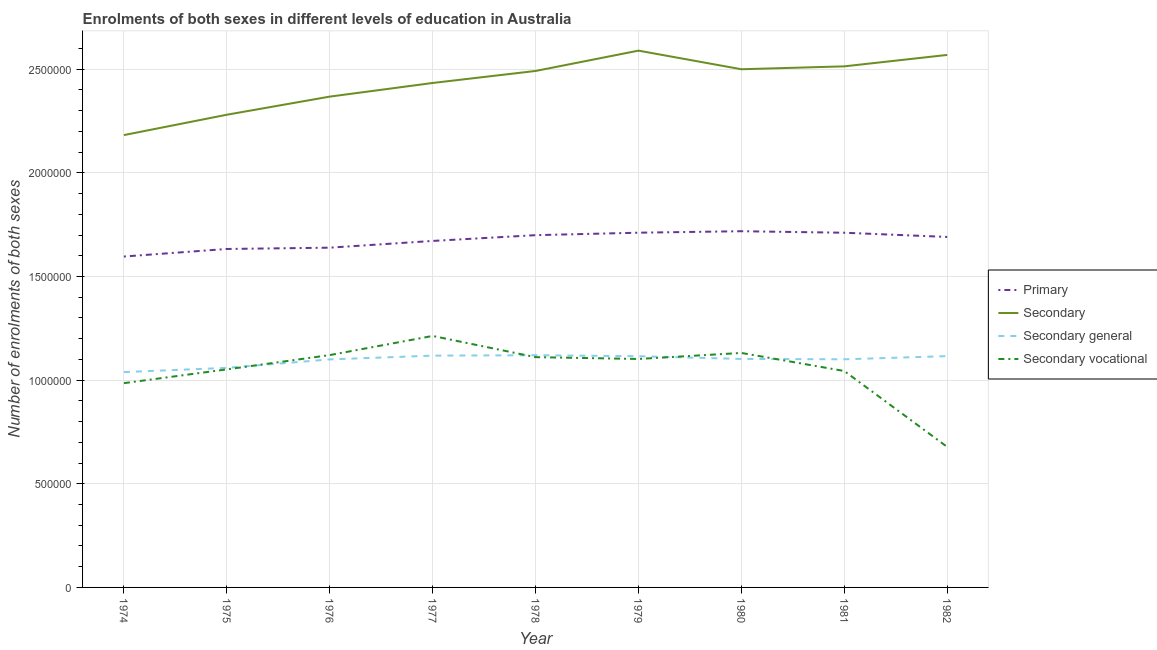Is the number of lines equal to the number of legend labels?
Keep it short and to the point. Yes. What is the number of enrolments in primary education in 1981?
Make the answer very short. 1.71e+06. Across all years, what is the maximum number of enrolments in secondary general education?
Your answer should be compact. 1.12e+06. Across all years, what is the minimum number of enrolments in secondary education?
Keep it short and to the point. 2.18e+06. In which year was the number of enrolments in secondary general education maximum?
Make the answer very short. 1978. In which year was the number of enrolments in secondary education minimum?
Your answer should be compact. 1974. What is the total number of enrolments in secondary general education in the graph?
Provide a succinct answer. 9.87e+06. What is the difference between the number of enrolments in secondary general education in 1978 and that in 1979?
Give a very brief answer. 4783. What is the difference between the number of enrolments in secondary education in 1982 and the number of enrolments in secondary vocational education in 1975?
Your answer should be compact. 1.52e+06. What is the average number of enrolments in secondary vocational education per year?
Your response must be concise. 1.05e+06. In the year 1976, what is the difference between the number of enrolments in secondary vocational education and number of enrolments in primary education?
Keep it short and to the point. -5.18e+05. In how many years, is the number of enrolments in secondary education greater than 400000?
Offer a terse response. 9. What is the ratio of the number of enrolments in secondary education in 1976 to that in 1979?
Your response must be concise. 0.91. What is the difference between the highest and the second highest number of enrolments in secondary general education?
Offer a terse response. 2012. What is the difference between the highest and the lowest number of enrolments in secondary education?
Give a very brief answer. 4.07e+05. In how many years, is the number of enrolments in secondary vocational education greater than the average number of enrolments in secondary vocational education taken over all years?
Offer a terse response. 6. Is the sum of the number of enrolments in primary education in 1976 and 1982 greater than the maximum number of enrolments in secondary education across all years?
Offer a very short reply. Yes. Is it the case that in every year, the sum of the number of enrolments in secondary education and number of enrolments in secondary general education is greater than the sum of number of enrolments in primary education and number of enrolments in secondary vocational education?
Your answer should be compact. No. Is the number of enrolments in secondary general education strictly greater than the number of enrolments in secondary vocational education over the years?
Make the answer very short. No. Is the number of enrolments in secondary vocational education strictly less than the number of enrolments in secondary education over the years?
Provide a succinct answer. Yes. How many years are there in the graph?
Offer a very short reply. 9. What is the difference between two consecutive major ticks on the Y-axis?
Ensure brevity in your answer.  5.00e+05. Are the values on the major ticks of Y-axis written in scientific E-notation?
Keep it short and to the point. No. How are the legend labels stacked?
Offer a terse response. Vertical. What is the title of the graph?
Your answer should be compact. Enrolments of both sexes in different levels of education in Australia. What is the label or title of the Y-axis?
Keep it short and to the point. Number of enrolments of both sexes. What is the Number of enrolments of both sexes in Primary in 1974?
Offer a terse response. 1.60e+06. What is the Number of enrolments of both sexes in Secondary in 1974?
Offer a terse response. 2.18e+06. What is the Number of enrolments of both sexes in Secondary general in 1974?
Offer a terse response. 1.04e+06. What is the Number of enrolments of both sexes in Secondary vocational in 1974?
Your response must be concise. 9.85e+05. What is the Number of enrolments of both sexes in Primary in 1975?
Make the answer very short. 1.63e+06. What is the Number of enrolments of both sexes in Secondary in 1975?
Offer a very short reply. 2.28e+06. What is the Number of enrolments of both sexes in Secondary general in 1975?
Offer a very short reply. 1.06e+06. What is the Number of enrolments of both sexes of Secondary vocational in 1975?
Your answer should be compact. 1.05e+06. What is the Number of enrolments of both sexes of Primary in 1976?
Offer a very short reply. 1.64e+06. What is the Number of enrolments of both sexes in Secondary in 1976?
Offer a terse response. 2.37e+06. What is the Number of enrolments of both sexes of Secondary general in 1976?
Provide a succinct answer. 1.10e+06. What is the Number of enrolments of both sexes of Secondary vocational in 1976?
Give a very brief answer. 1.12e+06. What is the Number of enrolments of both sexes in Primary in 1977?
Give a very brief answer. 1.67e+06. What is the Number of enrolments of both sexes of Secondary in 1977?
Give a very brief answer. 2.43e+06. What is the Number of enrolments of both sexes of Secondary general in 1977?
Your answer should be very brief. 1.12e+06. What is the Number of enrolments of both sexes in Secondary vocational in 1977?
Offer a terse response. 1.21e+06. What is the Number of enrolments of both sexes of Primary in 1978?
Keep it short and to the point. 1.70e+06. What is the Number of enrolments of both sexes of Secondary in 1978?
Make the answer very short. 2.49e+06. What is the Number of enrolments of both sexes of Secondary general in 1978?
Provide a succinct answer. 1.12e+06. What is the Number of enrolments of both sexes of Secondary vocational in 1978?
Your answer should be compact. 1.11e+06. What is the Number of enrolments of both sexes in Primary in 1979?
Your response must be concise. 1.71e+06. What is the Number of enrolments of both sexes of Secondary in 1979?
Your answer should be very brief. 2.59e+06. What is the Number of enrolments of both sexes in Secondary general in 1979?
Provide a succinct answer. 1.12e+06. What is the Number of enrolments of both sexes of Secondary vocational in 1979?
Ensure brevity in your answer.  1.10e+06. What is the Number of enrolments of both sexes of Primary in 1980?
Provide a short and direct response. 1.72e+06. What is the Number of enrolments of both sexes in Secondary in 1980?
Keep it short and to the point. 2.50e+06. What is the Number of enrolments of both sexes in Secondary general in 1980?
Ensure brevity in your answer.  1.10e+06. What is the Number of enrolments of both sexes in Secondary vocational in 1980?
Your response must be concise. 1.13e+06. What is the Number of enrolments of both sexes of Primary in 1981?
Your answer should be compact. 1.71e+06. What is the Number of enrolments of both sexes of Secondary in 1981?
Give a very brief answer. 2.51e+06. What is the Number of enrolments of both sexes of Secondary general in 1981?
Your answer should be compact. 1.10e+06. What is the Number of enrolments of both sexes of Secondary vocational in 1981?
Keep it short and to the point. 1.04e+06. What is the Number of enrolments of both sexes of Primary in 1982?
Your answer should be compact. 1.69e+06. What is the Number of enrolments of both sexes in Secondary in 1982?
Provide a short and direct response. 2.57e+06. What is the Number of enrolments of both sexes of Secondary general in 1982?
Offer a very short reply. 1.12e+06. What is the Number of enrolments of both sexes of Secondary vocational in 1982?
Keep it short and to the point. 6.78e+05. Across all years, what is the maximum Number of enrolments of both sexes of Primary?
Your response must be concise. 1.72e+06. Across all years, what is the maximum Number of enrolments of both sexes in Secondary?
Make the answer very short. 2.59e+06. Across all years, what is the maximum Number of enrolments of both sexes of Secondary general?
Your answer should be compact. 1.12e+06. Across all years, what is the maximum Number of enrolments of both sexes of Secondary vocational?
Provide a succinct answer. 1.21e+06. Across all years, what is the minimum Number of enrolments of both sexes in Primary?
Make the answer very short. 1.60e+06. Across all years, what is the minimum Number of enrolments of both sexes of Secondary?
Your answer should be compact. 2.18e+06. Across all years, what is the minimum Number of enrolments of both sexes in Secondary general?
Provide a short and direct response. 1.04e+06. Across all years, what is the minimum Number of enrolments of both sexes in Secondary vocational?
Make the answer very short. 6.78e+05. What is the total Number of enrolments of both sexes of Primary in the graph?
Offer a very short reply. 1.51e+07. What is the total Number of enrolments of both sexes in Secondary in the graph?
Provide a short and direct response. 2.19e+07. What is the total Number of enrolments of both sexes of Secondary general in the graph?
Offer a very short reply. 9.87e+06. What is the total Number of enrolments of both sexes in Secondary vocational in the graph?
Make the answer very short. 9.44e+06. What is the difference between the Number of enrolments of both sexes of Primary in 1974 and that in 1975?
Offer a terse response. -3.64e+04. What is the difference between the Number of enrolments of both sexes in Secondary in 1974 and that in 1975?
Make the answer very short. -9.82e+04. What is the difference between the Number of enrolments of both sexes in Secondary general in 1974 and that in 1975?
Offer a terse response. -2.04e+04. What is the difference between the Number of enrolments of both sexes in Secondary vocational in 1974 and that in 1975?
Provide a short and direct response. -6.64e+04. What is the difference between the Number of enrolments of both sexes of Primary in 1974 and that in 1976?
Provide a succinct answer. -4.27e+04. What is the difference between the Number of enrolments of both sexes of Secondary in 1974 and that in 1976?
Provide a succinct answer. -1.86e+05. What is the difference between the Number of enrolments of both sexes of Secondary general in 1974 and that in 1976?
Give a very brief answer. -6.11e+04. What is the difference between the Number of enrolments of both sexes of Secondary vocational in 1974 and that in 1976?
Your answer should be very brief. -1.35e+05. What is the difference between the Number of enrolments of both sexes in Primary in 1974 and that in 1977?
Your response must be concise. -7.52e+04. What is the difference between the Number of enrolments of both sexes of Secondary in 1974 and that in 1977?
Offer a terse response. -2.51e+05. What is the difference between the Number of enrolments of both sexes of Secondary general in 1974 and that in 1977?
Offer a very short reply. -7.94e+04. What is the difference between the Number of enrolments of both sexes in Secondary vocational in 1974 and that in 1977?
Your answer should be very brief. -2.28e+05. What is the difference between the Number of enrolments of both sexes of Primary in 1974 and that in 1978?
Provide a succinct answer. -1.03e+05. What is the difference between the Number of enrolments of both sexes in Secondary in 1974 and that in 1978?
Give a very brief answer. -3.09e+05. What is the difference between the Number of enrolments of both sexes in Secondary general in 1974 and that in 1978?
Keep it short and to the point. -8.14e+04. What is the difference between the Number of enrolments of both sexes of Secondary vocational in 1974 and that in 1978?
Ensure brevity in your answer.  -1.25e+05. What is the difference between the Number of enrolments of both sexes of Primary in 1974 and that in 1979?
Keep it short and to the point. -1.15e+05. What is the difference between the Number of enrolments of both sexes in Secondary in 1974 and that in 1979?
Your response must be concise. -4.07e+05. What is the difference between the Number of enrolments of both sexes in Secondary general in 1974 and that in 1979?
Keep it short and to the point. -7.66e+04. What is the difference between the Number of enrolments of both sexes in Secondary vocational in 1974 and that in 1979?
Provide a succinct answer. -1.17e+05. What is the difference between the Number of enrolments of both sexes in Primary in 1974 and that in 1980?
Offer a terse response. -1.22e+05. What is the difference between the Number of enrolments of both sexes of Secondary in 1974 and that in 1980?
Give a very brief answer. -3.18e+05. What is the difference between the Number of enrolments of both sexes of Secondary general in 1974 and that in 1980?
Keep it short and to the point. -6.34e+04. What is the difference between the Number of enrolments of both sexes in Secondary vocational in 1974 and that in 1980?
Your answer should be very brief. -1.46e+05. What is the difference between the Number of enrolments of both sexes in Primary in 1974 and that in 1981?
Provide a short and direct response. -1.15e+05. What is the difference between the Number of enrolments of both sexes of Secondary in 1974 and that in 1981?
Your response must be concise. -3.32e+05. What is the difference between the Number of enrolments of both sexes of Secondary general in 1974 and that in 1981?
Your answer should be very brief. -6.17e+04. What is the difference between the Number of enrolments of both sexes in Secondary vocational in 1974 and that in 1981?
Provide a succinct answer. -5.86e+04. What is the difference between the Number of enrolments of both sexes in Primary in 1974 and that in 1982?
Your response must be concise. -9.45e+04. What is the difference between the Number of enrolments of both sexes of Secondary in 1974 and that in 1982?
Make the answer very short. -3.87e+05. What is the difference between the Number of enrolments of both sexes of Secondary general in 1974 and that in 1982?
Keep it short and to the point. -7.70e+04. What is the difference between the Number of enrolments of both sexes of Secondary vocational in 1974 and that in 1982?
Make the answer very short. 3.08e+05. What is the difference between the Number of enrolments of both sexes in Primary in 1975 and that in 1976?
Your answer should be compact. -6239. What is the difference between the Number of enrolments of both sexes in Secondary in 1975 and that in 1976?
Your answer should be compact. -8.74e+04. What is the difference between the Number of enrolments of both sexes of Secondary general in 1975 and that in 1976?
Provide a succinct answer. -4.07e+04. What is the difference between the Number of enrolments of both sexes of Secondary vocational in 1975 and that in 1976?
Provide a succinct answer. -6.89e+04. What is the difference between the Number of enrolments of both sexes of Primary in 1975 and that in 1977?
Your answer should be very brief. -3.88e+04. What is the difference between the Number of enrolments of both sexes of Secondary in 1975 and that in 1977?
Offer a terse response. -1.53e+05. What is the difference between the Number of enrolments of both sexes of Secondary general in 1975 and that in 1977?
Make the answer very short. -5.90e+04. What is the difference between the Number of enrolments of both sexes in Secondary vocational in 1975 and that in 1977?
Keep it short and to the point. -1.61e+05. What is the difference between the Number of enrolments of both sexes of Primary in 1975 and that in 1978?
Make the answer very short. -6.66e+04. What is the difference between the Number of enrolments of both sexes of Secondary in 1975 and that in 1978?
Your answer should be compact. -2.11e+05. What is the difference between the Number of enrolments of both sexes of Secondary general in 1975 and that in 1978?
Make the answer very short. -6.10e+04. What is the difference between the Number of enrolments of both sexes of Secondary vocational in 1975 and that in 1978?
Ensure brevity in your answer.  -5.90e+04. What is the difference between the Number of enrolments of both sexes in Primary in 1975 and that in 1979?
Give a very brief answer. -7.85e+04. What is the difference between the Number of enrolments of both sexes of Secondary in 1975 and that in 1979?
Ensure brevity in your answer.  -3.09e+05. What is the difference between the Number of enrolments of both sexes in Secondary general in 1975 and that in 1979?
Your answer should be very brief. -5.62e+04. What is the difference between the Number of enrolments of both sexes in Secondary vocational in 1975 and that in 1979?
Ensure brevity in your answer.  -5.02e+04. What is the difference between the Number of enrolments of both sexes in Primary in 1975 and that in 1980?
Offer a very short reply. -8.56e+04. What is the difference between the Number of enrolments of both sexes in Secondary in 1975 and that in 1980?
Offer a terse response. -2.19e+05. What is the difference between the Number of enrolments of both sexes of Secondary general in 1975 and that in 1980?
Your response must be concise. -4.30e+04. What is the difference between the Number of enrolments of both sexes of Secondary vocational in 1975 and that in 1980?
Offer a terse response. -7.93e+04. What is the difference between the Number of enrolments of both sexes of Primary in 1975 and that in 1981?
Provide a succinct answer. -7.83e+04. What is the difference between the Number of enrolments of both sexes in Secondary in 1975 and that in 1981?
Your response must be concise. -2.33e+05. What is the difference between the Number of enrolments of both sexes in Secondary general in 1975 and that in 1981?
Your response must be concise. -4.13e+04. What is the difference between the Number of enrolments of both sexes of Secondary vocational in 1975 and that in 1981?
Provide a succinct answer. 7845. What is the difference between the Number of enrolments of both sexes in Primary in 1975 and that in 1982?
Give a very brief answer. -5.81e+04. What is the difference between the Number of enrolments of both sexes of Secondary in 1975 and that in 1982?
Ensure brevity in your answer.  -2.89e+05. What is the difference between the Number of enrolments of both sexes of Secondary general in 1975 and that in 1982?
Your answer should be compact. -5.66e+04. What is the difference between the Number of enrolments of both sexes of Secondary vocational in 1975 and that in 1982?
Provide a succinct answer. 3.74e+05. What is the difference between the Number of enrolments of both sexes in Primary in 1976 and that in 1977?
Keep it short and to the point. -3.26e+04. What is the difference between the Number of enrolments of both sexes of Secondary in 1976 and that in 1977?
Offer a very short reply. -6.58e+04. What is the difference between the Number of enrolments of both sexes in Secondary general in 1976 and that in 1977?
Provide a short and direct response. -1.82e+04. What is the difference between the Number of enrolments of both sexes of Secondary vocational in 1976 and that in 1977?
Your answer should be very brief. -9.24e+04. What is the difference between the Number of enrolments of both sexes in Primary in 1976 and that in 1978?
Your response must be concise. -6.04e+04. What is the difference between the Number of enrolments of both sexes of Secondary in 1976 and that in 1978?
Provide a succinct answer. -1.24e+05. What is the difference between the Number of enrolments of both sexes in Secondary general in 1976 and that in 1978?
Give a very brief answer. -2.02e+04. What is the difference between the Number of enrolments of both sexes of Secondary vocational in 1976 and that in 1978?
Your response must be concise. 9884. What is the difference between the Number of enrolments of both sexes of Primary in 1976 and that in 1979?
Provide a succinct answer. -7.23e+04. What is the difference between the Number of enrolments of both sexes of Secondary in 1976 and that in 1979?
Your answer should be very brief. -2.22e+05. What is the difference between the Number of enrolments of both sexes of Secondary general in 1976 and that in 1979?
Your response must be concise. -1.55e+04. What is the difference between the Number of enrolments of both sexes of Secondary vocational in 1976 and that in 1979?
Offer a terse response. 1.87e+04. What is the difference between the Number of enrolments of both sexes of Primary in 1976 and that in 1980?
Offer a very short reply. -7.94e+04. What is the difference between the Number of enrolments of both sexes of Secondary in 1976 and that in 1980?
Ensure brevity in your answer.  -1.32e+05. What is the difference between the Number of enrolments of both sexes in Secondary general in 1976 and that in 1980?
Make the answer very short. -2256. What is the difference between the Number of enrolments of both sexes of Secondary vocational in 1976 and that in 1980?
Your answer should be very brief. -1.04e+04. What is the difference between the Number of enrolments of both sexes in Primary in 1976 and that in 1981?
Give a very brief answer. -7.21e+04. What is the difference between the Number of enrolments of both sexes of Secondary in 1976 and that in 1981?
Your answer should be compact. -1.46e+05. What is the difference between the Number of enrolments of both sexes of Secondary general in 1976 and that in 1981?
Ensure brevity in your answer.  -546. What is the difference between the Number of enrolments of both sexes of Secondary vocational in 1976 and that in 1981?
Give a very brief answer. 7.67e+04. What is the difference between the Number of enrolments of both sexes of Primary in 1976 and that in 1982?
Your answer should be compact. -5.18e+04. What is the difference between the Number of enrolments of both sexes in Secondary in 1976 and that in 1982?
Keep it short and to the point. -2.01e+05. What is the difference between the Number of enrolments of both sexes of Secondary general in 1976 and that in 1982?
Make the answer very short. -1.59e+04. What is the difference between the Number of enrolments of both sexes in Secondary vocational in 1976 and that in 1982?
Make the answer very short. 4.43e+05. What is the difference between the Number of enrolments of both sexes in Primary in 1977 and that in 1978?
Give a very brief answer. -2.78e+04. What is the difference between the Number of enrolments of both sexes in Secondary in 1977 and that in 1978?
Make the answer very short. -5.80e+04. What is the difference between the Number of enrolments of both sexes in Secondary general in 1977 and that in 1978?
Ensure brevity in your answer.  -2012. What is the difference between the Number of enrolments of both sexes of Secondary vocational in 1977 and that in 1978?
Offer a very short reply. 1.02e+05. What is the difference between the Number of enrolments of both sexes in Primary in 1977 and that in 1979?
Give a very brief answer. -3.97e+04. What is the difference between the Number of enrolments of both sexes in Secondary in 1977 and that in 1979?
Provide a succinct answer. -1.56e+05. What is the difference between the Number of enrolments of both sexes of Secondary general in 1977 and that in 1979?
Provide a succinct answer. 2771. What is the difference between the Number of enrolments of both sexes of Secondary vocational in 1977 and that in 1979?
Ensure brevity in your answer.  1.11e+05. What is the difference between the Number of enrolments of both sexes in Primary in 1977 and that in 1980?
Your response must be concise. -4.68e+04. What is the difference between the Number of enrolments of both sexes in Secondary in 1977 and that in 1980?
Your response must be concise. -6.62e+04. What is the difference between the Number of enrolments of both sexes of Secondary general in 1977 and that in 1980?
Make the answer very short. 1.60e+04. What is the difference between the Number of enrolments of both sexes in Secondary vocational in 1977 and that in 1980?
Your response must be concise. 8.21e+04. What is the difference between the Number of enrolments of both sexes of Primary in 1977 and that in 1981?
Provide a succinct answer. -3.95e+04. What is the difference between the Number of enrolments of both sexes in Secondary in 1977 and that in 1981?
Offer a very short reply. -8.02e+04. What is the difference between the Number of enrolments of both sexes in Secondary general in 1977 and that in 1981?
Give a very brief answer. 1.77e+04. What is the difference between the Number of enrolments of both sexes in Secondary vocational in 1977 and that in 1981?
Provide a short and direct response. 1.69e+05. What is the difference between the Number of enrolments of both sexes in Primary in 1977 and that in 1982?
Offer a very short reply. -1.93e+04. What is the difference between the Number of enrolments of both sexes in Secondary in 1977 and that in 1982?
Offer a terse response. -1.35e+05. What is the difference between the Number of enrolments of both sexes of Secondary general in 1977 and that in 1982?
Your response must be concise. 2367. What is the difference between the Number of enrolments of both sexes in Secondary vocational in 1977 and that in 1982?
Make the answer very short. 5.35e+05. What is the difference between the Number of enrolments of both sexes in Primary in 1978 and that in 1979?
Your response must be concise. -1.19e+04. What is the difference between the Number of enrolments of both sexes of Secondary in 1978 and that in 1979?
Make the answer very short. -9.81e+04. What is the difference between the Number of enrolments of both sexes of Secondary general in 1978 and that in 1979?
Ensure brevity in your answer.  4783. What is the difference between the Number of enrolments of both sexes of Secondary vocational in 1978 and that in 1979?
Provide a succinct answer. 8817. What is the difference between the Number of enrolments of both sexes in Primary in 1978 and that in 1980?
Provide a succinct answer. -1.90e+04. What is the difference between the Number of enrolments of both sexes of Secondary in 1978 and that in 1980?
Your answer should be compact. -8272. What is the difference between the Number of enrolments of both sexes in Secondary general in 1978 and that in 1980?
Your answer should be compact. 1.80e+04. What is the difference between the Number of enrolments of both sexes in Secondary vocational in 1978 and that in 1980?
Make the answer very short. -2.02e+04. What is the difference between the Number of enrolments of both sexes of Primary in 1978 and that in 1981?
Ensure brevity in your answer.  -1.17e+04. What is the difference between the Number of enrolments of both sexes of Secondary in 1978 and that in 1981?
Keep it short and to the point. -2.23e+04. What is the difference between the Number of enrolments of both sexes of Secondary general in 1978 and that in 1981?
Offer a terse response. 1.97e+04. What is the difference between the Number of enrolments of both sexes of Secondary vocational in 1978 and that in 1981?
Your response must be concise. 6.69e+04. What is the difference between the Number of enrolments of both sexes of Primary in 1978 and that in 1982?
Give a very brief answer. 8527. What is the difference between the Number of enrolments of both sexes in Secondary in 1978 and that in 1982?
Provide a succinct answer. -7.74e+04. What is the difference between the Number of enrolments of both sexes in Secondary general in 1978 and that in 1982?
Offer a terse response. 4379. What is the difference between the Number of enrolments of both sexes of Secondary vocational in 1978 and that in 1982?
Ensure brevity in your answer.  4.33e+05. What is the difference between the Number of enrolments of both sexes of Primary in 1979 and that in 1980?
Make the answer very short. -7120. What is the difference between the Number of enrolments of both sexes in Secondary in 1979 and that in 1980?
Give a very brief answer. 8.98e+04. What is the difference between the Number of enrolments of both sexes of Secondary general in 1979 and that in 1980?
Ensure brevity in your answer.  1.32e+04. What is the difference between the Number of enrolments of both sexes in Secondary vocational in 1979 and that in 1980?
Provide a succinct answer. -2.91e+04. What is the difference between the Number of enrolments of both sexes in Primary in 1979 and that in 1981?
Provide a succinct answer. 195. What is the difference between the Number of enrolments of both sexes of Secondary in 1979 and that in 1981?
Offer a very short reply. 7.58e+04. What is the difference between the Number of enrolments of both sexes in Secondary general in 1979 and that in 1981?
Keep it short and to the point. 1.49e+04. What is the difference between the Number of enrolments of both sexes in Secondary vocational in 1979 and that in 1981?
Offer a terse response. 5.80e+04. What is the difference between the Number of enrolments of both sexes in Primary in 1979 and that in 1982?
Provide a short and direct response. 2.05e+04. What is the difference between the Number of enrolments of both sexes in Secondary in 1979 and that in 1982?
Offer a very short reply. 2.07e+04. What is the difference between the Number of enrolments of both sexes of Secondary general in 1979 and that in 1982?
Your response must be concise. -404. What is the difference between the Number of enrolments of both sexes of Secondary vocational in 1979 and that in 1982?
Keep it short and to the point. 4.24e+05. What is the difference between the Number of enrolments of both sexes of Primary in 1980 and that in 1981?
Make the answer very short. 7315. What is the difference between the Number of enrolments of both sexes of Secondary in 1980 and that in 1981?
Ensure brevity in your answer.  -1.40e+04. What is the difference between the Number of enrolments of both sexes in Secondary general in 1980 and that in 1981?
Your answer should be compact. 1710. What is the difference between the Number of enrolments of both sexes in Secondary vocational in 1980 and that in 1981?
Provide a succinct answer. 8.71e+04. What is the difference between the Number of enrolments of both sexes of Primary in 1980 and that in 1982?
Your response must be concise. 2.76e+04. What is the difference between the Number of enrolments of both sexes of Secondary in 1980 and that in 1982?
Provide a short and direct response. -6.91e+04. What is the difference between the Number of enrolments of both sexes of Secondary general in 1980 and that in 1982?
Provide a succinct answer. -1.36e+04. What is the difference between the Number of enrolments of both sexes of Secondary vocational in 1980 and that in 1982?
Provide a succinct answer. 4.53e+05. What is the difference between the Number of enrolments of both sexes of Primary in 1981 and that in 1982?
Provide a succinct answer. 2.03e+04. What is the difference between the Number of enrolments of both sexes of Secondary in 1981 and that in 1982?
Provide a short and direct response. -5.51e+04. What is the difference between the Number of enrolments of both sexes in Secondary general in 1981 and that in 1982?
Provide a succinct answer. -1.53e+04. What is the difference between the Number of enrolments of both sexes in Secondary vocational in 1981 and that in 1982?
Give a very brief answer. 3.66e+05. What is the difference between the Number of enrolments of both sexes in Primary in 1974 and the Number of enrolments of both sexes in Secondary in 1975?
Provide a succinct answer. -6.84e+05. What is the difference between the Number of enrolments of both sexes in Primary in 1974 and the Number of enrolments of both sexes in Secondary general in 1975?
Offer a very short reply. 5.37e+05. What is the difference between the Number of enrolments of both sexes of Primary in 1974 and the Number of enrolments of both sexes of Secondary vocational in 1975?
Your answer should be very brief. 5.44e+05. What is the difference between the Number of enrolments of both sexes in Secondary in 1974 and the Number of enrolments of both sexes in Secondary general in 1975?
Your response must be concise. 1.12e+06. What is the difference between the Number of enrolments of both sexes in Secondary in 1974 and the Number of enrolments of both sexes in Secondary vocational in 1975?
Your answer should be compact. 1.13e+06. What is the difference between the Number of enrolments of both sexes in Secondary general in 1974 and the Number of enrolments of both sexes in Secondary vocational in 1975?
Your response must be concise. -1.31e+04. What is the difference between the Number of enrolments of both sexes in Primary in 1974 and the Number of enrolments of both sexes in Secondary in 1976?
Offer a terse response. -7.71e+05. What is the difference between the Number of enrolments of both sexes of Primary in 1974 and the Number of enrolments of both sexes of Secondary general in 1976?
Provide a short and direct response. 4.96e+05. What is the difference between the Number of enrolments of both sexes in Primary in 1974 and the Number of enrolments of both sexes in Secondary vocational in 1976?
Offer a terse response. 4.76e+05. What is the difference between the Number of enrolments of both sexes of Secondary in 1974 and the Number of enrolments of both sexes of Secondary general in 1976?
Your response must be concise. 1.08e+06. What is the difference between the Number of enrolments of both sexes in Secondary in 1974 and the Number of enrolments of both sexes in Secondary vocational in 1976?
Offer a very short reply. 1.06e+06. What is the difference between the Number of enrolments of both sexes of Secondary general in 1974 and the Number of enrolments of both sexes of Secondary vocational in 1976?
Your answer should be very brief. -8.20e+04. What is the difference between the Number of enrolments of both sexes of Primary in 1974 and the Number of enrolments of both sexes of Secondary in 1977?
Offer a very short reply. -8.37e+05. What is the difference between the Number of enrolments of both sexes of Primary in 1974 and the Number of enrolments of both sexes of Secondary general in 1977?
Keep it short and to the point. 4.78e+05. What is the difference between the Number of enrolments of both sexes of Primary in 1974 and the Number of enrolments of both sexes of Secondary vocational in 1977?
Ensure brevity in your answer.  3.83e+05. What is the difference between the Number of enrolments of both sexes in Secondary in 1974 and the Number of enrolments of both sexes in Secondary general in 1977?
Your answer should be compact. 1.06e+06. What is the difference between the Number of enrolments of both sexes in Secondary in 1974 and the Number of enrolments of both sexes in Secondary vocational in 1977?
Ensure brevity in your answer.  9.69e+05. What is the difference between the Number of enrolments of both sexes of Secondary general in 1974 and the Number of enrolments of both sexes of Secondary vocational in 1977?
Your response must be concise. -1.74e+05. What is the difference between the Number of enrolments of both sexes in Primary in 1974 and the Number of enrolments of both sexes in Secondary in 1978?
Offer a terse response. -8.95e+05. What is the difference between the Number of enrolments of both sexes in Primary in 1974 and the Number of enrolments of both sexes in Secondary general in 1978?
Ensure brevity in your answer.  4.76e+05. What is the difference between the Number of enrolments of both sexes in Primary in 1974 and the Number of enrolments of both sexes in Secondary vocational in 1978?
Offer a terse response. 4.85e+05. What is the difference between the Number of enrolments of both sexes of Secondary in 1974 and the Number of enrolments of both sexes of Secondary general in 1978?
Your response must be concise. 1.06e+06. What is the difference between the Number of enrolments of both sexes of Secondary in 1974 and the Number of enrolments of both sexes of Secondary vocational in 1978?
Make the answer very short. 1.07e+06. What is the difference between the Number of enrolments of both sexes of Secondary general in 1974 and the Number of enrolments of both sexes of Secondary vocational in 1978?
Make the answer very short. -7.21e+04. What is the difference between the Number of enrolments of both sexes of Primary in 1974 and the Number of enrolments of both sexes of Secondary in 1979?
Provide a short and direct response. -9.93e+05. What is the difference between the Number of enrolments of both sexes in Primary in 1974 and the Number of enrolments of both sexes in Secondary general in 1979?
Keep it short and to the point. 4.81e+05. What is the difference between the Number of enrolments of both sexes in Primary in 1974 and the Number of enrolments of both sexes in Secondary vocational in 1979?
Give a very brief answer. 4.94e+05. What is the difference between the Number of enrolments of both sexes of Secondary in 1974 and the Number of enrolments of both sexes of Secondary general in 1979?
Offer a very short reply. 1.07e+06. What is the difference between the Number of enrolments of both sexes in Secondary in 1974 and the Number of enrolments of both sexes in Secondary vocational in 1979?
Provide a succinct answer. 1.08e+06. What is the difference between the Number of enrolments of both sexes of Secondary general in 1974 and the Number of enrolments of both sexes of Secondary vocational in 1979?
Ensure brevity in your answer.  -6.33e+04. What is the difference between the Number of enrolments of both sexes of Primary in 1974 and the Number of enrolments of both sexes of Secondary in 1980?
Provide a succinct answer. -9.03e+05. What is the difference between the Number of enrolments of both sexes in Primary in 1974 and the Number of enrolments of both sexes in Secondary general in 1980?
Provide a succinct answer. 4.94e+05. What is the difference between the Number of enrolments of both sexes of Primary in 1974 and the Number of enrolments of both sexes of Secondary vocational in 1980?
Give a very brief answer. 4.65e+05. What is the difference between the Number of enrolments of both sexes in Secondary in 1974 and the Number of enrolments of both sexes in Secondary general in 1980?
Your answer should be very brief. 1.08e+06. What is the difference between the Number of enrolments of both sexes in Secondary in 1974 and the Number of enrolments of both sexes in Secondary vocational in 1980?
Keep it short and to the point. 1.05e+06. What is the difference between the Number of enrolments of both sexes in Secondary general in 1974 and the Number of enrolments of both sexes in Secondary vocational in 1980?
Ensure brevity in your answer.  -9.23e+04. What is the difference between the Number of enrolments of both sexes of Primary in 1974 and the Number of enrolments of both sexes of Secondary in 1981?
Make the answer very short. -9.17e+05. What is the difference between the Number of enrolments of both sexes of Primary in 1974 and the Number of enrolments of both sexes of Secondary general in 1981?
Offer a very short reply. 4.96e+05. What is the difference between the Number of enrolments of both sexes of Primary in 1974 and the Number of enrolments of both sexes of Secondary vocational in 1981?
Offer a terse response. 5.52e+05. What is the difference between the Number of enrolments of both sexes in Secondary in 1974 and the Number of enrolments of both sexes in Secondary general in 1981?
Offer a very short reply. 1.08e+06. What is the difference between the Number of enrolments of both sexes of Secondary in 1974 and the Number of enrolments of both sexes of Secondary vocational in 1981?
Your response must be concise. 1.14e+06. What is the difference between the Number of enrolments of both sexes in Secondary general in 1974 and the Number of enrolments of both sexes in Secondary vocational in 1981?
Offer a terse response. -5238. What is the difference between the Number of enrolments of both sexes of Primary in 1974 and the Number of enrolments of both sexes of Secondary in 1982?
Offer a terse response. -9.73e+05. What is the difference between the Number of enrolments of both sexes of Primary in 1974 and the Number of enrolments of both sexes of Secondary general in 1982?
Give a very brief answer. 4.80e+05. What is the difference between the Number of enrolments of both sexes in Primary in 1974 and the Number of enrolments of both sexes in Secondary vocational in 1982?
Your answer should be very brief. 9.18e+05. What is the difference between the Number of enrolments of both sexes in Secondary in 1974 and the Number of enrolments of both sexes in Secondary general in 1982?
Give a very brief answer. 1.07e+06. What is the difference between the Number of enrolments of both sexes of Secondary in 1974 and the Number of enrolments of both sexes of Secondary vocational in 1982?
Your answer should be compact. 1.50e+06. What is the difference between the Number of enrolments of both sexes in Secondary general in 1974 and the Number of enrolments of both sexes in Secondary vocational in 1982?
Your answer should be very brief. 3.61e+05. What is the difference between the Number of enrolments of both sexes in Primary in 1975 and the Number of enrolments of both sexes in Secondary in 1976?
Provide a short and direct response. -7.35e+05. What is the difference between the Number of enrolments of both sexes in Primary in 1975 and the Number of enrolments of both sexes in Secondary general in 1976?
Give a very brief answer. 5.33e+05. What is the difference between the Number of enrolments of both sexes in Primary in 1975 and the Number of enrolments of both sexes in Secondary vocational in 1976?
Offer a terse response. 5.12e+05. What is the difference between the Number of enrolments of both sexes in Secondary in 1975 and the Number of enrolments of both sexes in Secondary general in 1976?
Give a very brief answer. 1.18e+06. What is the difference between the Number of enrolments of both sexes in Secondary in 1975 and the Number of enrolments of both sexes in Secondary vocational in 1976?
Offer a terse response. 1.16e+06. What is the difference between the Number of enrolments of both sexes in Secondary general in 1975 and the Number of enrolments of both sexes in Secondary vocational in 1976?
Your response must be concise. -6.16e+04. What is the difference between the Number of enrolments of both sexes in Primary in 1975 and the Number of enrolments of both sexes in Secondary in 1977?
Provide a succinct answer. -8.01e+05. What is the difference between the Number of enrolments of both sexes in Primary in 1975 and the Number of enrolments of both sexes in Secondary general in 1977?
Offer a terse response. 5.15e+05. What is the difference between the Number of enrolments of both sexes of Primary in 1975 and the Number of enrolments of both sexes of Secondary vocational in 1977?
Ensure brevity in your answer.  4.20e+05. What is the difference between the Number of enrolments of both sexes of Secondary in 1975 and the Number of enrolments of both sexes of Secondary general in 1977?
Your answer should be compact. 1.16e+06. What is the difference between the Number of enrolments of both sexes of Secondary in 1975 and the Number of enrolments of both sexes of Secondary vocational in 1977?
Give a very brief answer. 1.07e+06. What is the difference between the Number of enrolments of both sexes of Secondary general in 1975 and the Number of enrolments of both sexes of Secondary vocational in 1977?
Provide a succinct answer. -1.54e+05. What is the difference between the Number of enrolments of both sexes of Primary in 1975 and the Number of enrolments of both sexes of Secondary in 1978?
Your response must be concise. -8.59e+05. What is the difference between the Number of enrolments of both sexes in Primary in 1975 and the Number of enrolments of both sexes in Secondary general in 1978?
Make the answer very short. 5.13e+05. What is the difference between the Number of enrolments of both sexes of Primary in 1975 and the Number of enrolments of both sexes of Secondary vocational in 1978?
Your answer should be very brief. 5.22e+05. What is the difference between the Number of enrolments of both sexes in Secondary in 1975 and the Number of enrolments of both sexes in Secondary general in 1978?
Give a very brief answer. 1.16e+06. What is the difference between the Number of enrolments of both sexes of Secondary in 1975 and the Number of enrolments of both sexes of Secondary vocational in 1978?
Provide a succinct answer. 1.17e+06. What is the difference between the Number of enrolments of both sexes in Secondary general in 1975 and the Number of enrolments of both sexes in Secondary vocational in 1978?
Ensure brevity in your answer.  -5.17e+04. What is the difference between the Number of enrolments of both sexes of Primary in 1975 and the Number of enrolments of both sexes of Secondary in 1979?
Your answer should be very brief. -9.57e+05. What is the difference between the Number of enrolments of both sexes in Primary in 1975 and the Number of enrolments of both sexes in Secondary general in 1979?
Provide a succinct answer. 5.17e+05. What is the difference between the Number of enrolments of both sexes in Primary in 1975 and the Number of enrolments of both sexes in Secondary vocational in 1979?
Your response must be concise. 5.31e+05. What is the difference between the Number of enrolments of both sexes of Secondary in 1975 and the Number of enrolments of both sexes of Secondary general in 1979?
Make the answer very short. 1.16e+06. What is the difference between the Number of enrolments of both sexes in Secondary in 1975 and the Number of enrolments of both sexes in Secondary vocational in 1979?
Offer a terse response. 1.18e+06. What is the difference between the Number of enrolments of both sexes of Secondary general in 1975 and the Number of enrolments of both sexes of Secondary vocational in 1979?
Give a very brief answer. -4.29e+04. What is the difference between the Number of enrolments of both sexes in Primary in 1975 and the Number of enrolments of both sexes in Secondary in 1980?
Offer a very short reply. -8.67e+05. What is the difference between the Number of enrolments of both sexes in Primary in 1975 and the Number of enrolments of both sexes in Secondary general in 1980?
Provide a succinct answer. 5.31e+05. What is the difference between the Number of enrolments of both sexes in Primary in 1975 and the Number of enrolments of both sexes in Secondary vocational in 1980?
Ensure brevity in your answer.  5.02e+05. What is the difference between the Number of enrolments of both sexes of Secondary in 1975 and the Number of enrolments of both sexes of Secondary general in 1980?
Your answer should be very brief. 1.18e+06. What is the difference between the Number of enrolments of both sexes of Secondary in 1975 and the Number of enrolments of both sexes of Secondary vocational in 1980?
Your answer should be very brief. 1.15e+06. What is the difference between the Number of enrolments of both sexes of Secondary general in 1975 and the Number of enrolments of both sexes of Secondary vocational in 1980?
Provide a short and direct response. -7.19e+04. What is the difference between the Number of enrolments of both sexes in Primary in 1975 and the Number of enrolments of both sexes in Secondary in 1981?
Your answer should be compact. -8.81e+05. What is the difference between the Number of enrolments of both sexes of Primary in 1975 and the Number of enrolments of both sexes of Secondary general in 1981?
Keep it short and to the point. 5.32e+05. What is the difference between the Number of enrolments of both sexes in Primary in 1975 and the Number of enrolments of both sexes in Secondary vocational in 1981?
Keep it short and to the point. 5.89e+05. What is the difference between the Number of enrolments of both sexes of Secondary in 1975 and the Number of enrolments of both sexes of Secondary general in 1981?
Make the answer very short. 1.18e+06. What is the difference between the Number of enrolments of both sexes in Secondary in 1975 and the Number of enrolments of both sexes in Secondary vocational in 1981?
Offer a very short reply. 1.24e+06. What is the difference between the Number of enrolments of both sexes of Secondary general in 1975 and the Number of enrolments of both sexes of Secondary vocational in 1981?
Your answer should be very brief. 1.52e+04. What is the difference between the Number of enrolments of both sexes in Primary in 1975 and the Number of enrolments of both sexes in Secondary in 1982?
Provide a short and direct response. -9.36e+05. What is the difference between the Number of enrolments of both sexes of Primary in 1975 and the Number of enrolments of both sexes of Secondary general in 1982?
Give a very brief answer. 5.17e+05. What is the difference between the Number of enrolments of both sexes in Primary in 1975 and the Number of enrolments of both sexes in Secondary vocational in 1982?
Make the answer very short. 9.55e+05. What is the difference between the Number of enrolments of both sexes of Secondary in 1975 and the Number of enrolments of both sexes of Secondary general in 1982?
Offer a very short reply. 1.16e+06. What is the difference between the Number of enrolments of both sexes in Secondary in 1975 and the Number of enrolments of both sexes in Secondary vocational in 1982?
Offer a terse response. 1.60e+06. What is the difference between the Number of enrolments of both sexes of Secondary general in 1975 and the Number of enrolments of both sexes of Secondary vocational in 1982?
Offer a terse response. 3.81e+05. What is the difference between the Number of enrolments of both sexes in Primary in 1976 and the Number of enrolments of both sexes in Secondary in 1977?
Your response must be concise. -7.94e+05. What is the difference between the Number of enrolments of both sexes in Primary in 1976 and the Number of enrolments of both sexes in Secondary general in 1977?
Make the answer very short. 5.21e+05. What is the difference between the Number of enrolments of both sexes in Primary in 1976 and the Number of enrolments of both sexes in Secondary vocational in 1977?
Make the answer very short. 4.26e+05. What is the difference between the Number of enrolments of both sexes of Secondary in 1976 and the Number of enrolments of both sexes of Secondary general in 1977?
Your response must be concise. 1.25e+06. What is the difference between the Number of enrolments of both sexes of Secondary in 1976 and the Number of enrolments of both sexes of Secondary vocational in 1977?
Your answer should be very brief. 1.15e+06. What is the difference between the Number of enrolments of both sexes in Secondary general in 1976 and the Number of enrolments of both sexes in Secondary vocational in 1977?
Make the answer very short. -1.13e+05. What is the difference between the Number of enrolments of both sexes in Primary in 1976 and the Number of enrolments of both sexes in Secondary in 1978?
Offer a very short reply. -8.52e+05. What is the difference between the Number of enrolments of both sexes of Primary in 1976 and the Number of enrolments of both sexes of Secondary general in 1978?
Offer a terse response. 5.19e+05. What is the difference between the Number of enrolments of both sexes in Primary in 1976 and the Number of enrolments of both sexes in Secondary vocational in 1978?
Keep it short and to the point. 5.28e+05. What is the difference between the Number of enrolments of both sexes of Secondary in 1976 and the Number of enrolments of both sexes of Secondary general in 1978?
Offer a terse response. 1.25e+06. What is the difference between the Number of enrolments of both sexes of Secondary in 1976 and the Number of enrolments of both sexes of Secondary vocational in 1978?
Your answer should be compact. 1.26e+06. What is the difference between the Number of enrolments of both sexes in Secondary general in 1976 and the Number of enrolments of both sexes in Secondary vocational in 1978?
Offer a very short reply. -1.10e+04. What is the difference between the Number of enrolments of both sexes in Primary in 1976 and the Number of enrolments of both sexes in Secondary in 1979?
Your response must be concise. -9.51e+05. What is the difference between the Number of enrolments of both sexes in Primary in 1976 and the Number of enrolments of both sexes in Secondary general in 1979?
Your response must be concise. 5.24e+05. What is the difference between the Number of enrolments of both sexes in Primary in 1976 and the Number of enrolments of both sexes in Secondary vocational in 1979?
Offer a very short reply. 5.37e+05. What is the difference between the Number of enrolments of both sexes in Secondary in 1976 and the Number of enrolments of both sexes in Secondary general in 1979?
Offer a very short reply. 1.25e+06. What is the difference between the Number of enrolments of both sexes of Secondary in 1976 and the Number of enrolments of both sexes of Secondary vocational in 1979?
Provide a succinct answer. 1.27e+06. What is the difference between the Number of enrolments of both sexes in Secondary general in 1976 and the Number of enrolments of both sexes in Secondary vocational in 1979?
Keep it short and to the point. -2136. What is the difference between the Number of enrolments of both sexes of Primary in 1976 and the Number of enrolments of both sexes of Secondary in 1980?
Give a very brief answer. -8.61e+05. What is the difference between the Number of enrolments of both sexes of Primary in 1976 and the Number of enrolments of both sexes of Secondary general in 1980?
Your response must be concise. 5.37e+05. What is the difference between the Number of enrolments of both sexes of Primary in 1976 and the Number of enrolments of both sexes of Secondary vocational in 1980?
Provide a succinct answer. 5.08e+05. What is the difference between the Number of enrolments of both sexes in Secondary in 1976 and the Number of enrolments of both sexes in Secondary general in 1980?
Give a very brief answer. 1.27e+06. What is the difference between the Number of enrolments of both sexes in Secondary in 1976 and the Number of enrolments of both sexes in Secondary vocational in 1980?
Your answer should be compact. 1.24e+06. What is the difference between the Number of enrolments of both sexes of Secondary general in 1976 and the Number of enrolments of both sexes of Secondary vocational in 1980?
Make the answer very short. -3.12e+04. What is the difference between the Number of enrolments of both sexes in Primary in 1976 and the Number of enrolments of both sexes in Secondary in 1981?
Provide a short and direct response. -8.75e+05. What is the difference between the Number of enrolments of both sexes of Primary in 1976 and the Number of enrolments of both sexes of Secondary general in 1981?
Provide a succinct answer. 5.38e+05. What is the difference between the Number of enrolments of both sexes of Primary in 1976 and the Number of enrolments of both sexes of Secondary vocational in 1981?
Make the answer very short. 5.95e+05. What is the difference between the Number of enrolments of both sexes in Secondary in 1976 and the Number of enrolments of both sexes in Secondary general in 1981?
Keep it short and to the point. 1.27e+06. What is the difference between the Number of enrolments of both sexes of Secondary in 1976 and the Number of enrolments of both sexes of Secondary vocational in 1981?
Your response must be concise. 1.32e+06. What is the difference between the Number of enrolments of both sexes in Secondary general in 1976 and the Number of enrolments of both sexes in Secondary vocational in 1981?
Your answer should be compact. 5.59e+04. What is the difference between the Number of enrolments of both sexes in Primary in 1976 and the Number of enrolments of both sexes in Secondary in 1982?
Offer a terse response. -9.30e+05. What is the difference between the Number of enrolments of both sexes of Primary in 1976 and the Number of enrolments of both sexes of Secondary general in 1982?
Your response must be concise. 5.23e+05. What is the difference between the Number of enrolments of both sexes of Primary in 1976 and the Number of enrolments of both sexes of Secondary vocational in 1982?
Offer a very short reply. 9.61e+05. What is the difference between the Number of enrolments of both sexes in Secondary in 1976 and the Number of enrolments of both sexes in Secondary general in 1982?
Ensure brevity in your answer.  1.25e+06. What is the difference between the Number of enrolments of both sexes in Secondary in 1976 and the Number of enrolments of both sexes in Secondary vocational in 1982?
Your response must be concise. 1.69e+06. What is the difference between the Number of enrolments of both sexes in Secondary general in 1976 and the Number of enrolments of both sexes in Secondary vocational in 1982?
Ensure brevity in your answer.  4.22e+05. What is the difference between the Number of enrolments of both sexes in Primary in 1977 and the Number of enrolments of both sexes in Secondary in 1978?
Provide a succinct answer. -8.20e+05. What is the difference between the Number of enrolments of both sexes in Primary in 1977 and the Number of enrolments of both sexes in Secondary general in 1978?
Give a very brief answer. 5.51e+05. What is the difference between the Number of enrolments of both sexes of Primary in 1977 and the Number of enrolments of both sexes of Secondary vocational in 1978?
Offer a very short reply. 5.61e+05. What is the difference between the Number of enrolments of both sexes of Secondary in 1977 and the Number of enrolments of both sexes of Secondary general in 1978?
Ensure brevity in your answer.  1.31e+06. What is the difference between the Number of enrolments of both sexes in Secondary in 1977 and the Number of enrolments of both sexes in Secondary vocational in 1978?
Provide a succinct answer. 1.32e+06. What is the difference between the Number of enrolments of both sexes of Secondary general in 1977 and the Number of enrolments of both sexes of Secondary vocational in 1978?
Make the answer very short. 7274. What is the difference between the Number of enrolments of both sexes of Primary in 1977 and the Number of enrolments of both sexes of Secondary in 1979?
Make the answer very short. -9.18e+05. What is the difference between the Number of enrolments of both sexes of Primary in 1977 and the Number of enrolments of both sexes of Secondary general in 1979?
Ensure brevity in your answer.  5.56e+05. What is the difference between the Number of enrolments of both sexes of Primary in 1977 and the Number of enrolments of both sexes of Secondary vocational in 1979?
Keep it short and to the point. 5.69e+05. What is the difference between the Number of enrolments of both sexes of Secondary in 1977 and the Number of enrolments of both sexes of Secondary general in 1979?
Your answer should be compact. 1.32e+06. What is the difference between the Number of enrolments of both sexes of Secondary in 1977 and the Number of enrolments of both sexes of Secondary vocational in 1979?
Your answer should be very brief. 1.33e+06. What is the difference between the Number of enrolments of both sexes in Secondary general in 1977 and the Number of enrolments of both sexes in Secondary vocational in 1979?
Give a very brief answer. 1.61e+04. What is the difference between the Number of enrolments of both sexes in Primary in 1977 and the Number of enrolments of both sexes in Secondary in 1980?
Provide a succinct answer. -8.28e+05. What is the difference between the Number of enrolments of both sexes in Primary in 1977 and the Number of enrolments of both sexes in Secondary general in 1980?
Offer a terse response. 5.69e+05. What is the difference between the Number of enrolments of both sexes of Primary in 1977 and the Number of enrolments of both sexes of Secondary vocational in 1980?
Provide a short and direct response. 5.40e+05. What is the difference between the Number of enrolments of both sexes of Secondary in 1977 and the Number of enrolments of both sexes of Secondary general in 1980?
Keep it short and to the point. 1.33e+06. What is the difference between the Number of enrolments of both sexes in Secondary in 1977 and the Number of enrolments of both sexes in Secondary vocational in 1980?
Your response must be concise. 1.30e+06. What is the difference between the Number of enrolments of both sexes in Secondary general in 1977 and the Number of enrolments of both sexes in Secondary vocational in 1980?
Offer a terse response. -1.30e+04. What is the difference between the Number of enrolments of both sexes in Primary in 1977 and the Number of enrolments of both sexes in Secondary in 1981?
Keep it short and to the point. -8.42e+05. What is the difference between the Number of enrolments of both sexes of Primary in 1977 and the Number of enrolments of both sexes of Secondary general in 1981?
Your answer should be very brief. 5.71e+05. What is the difference between the Number of enrolments of both sexes of Primary in 1977 and the Number of enrolments of both sexes of Secondary vocational in 1981?
Keep it short and to the point. 6.28e+05. What is the difference between the Number of enrolments of both sexes in Secondary in 1977 and the Number of enrolments of both sexes in Secondary general in 1981?
Offer a very short reply. 1.33e+06. What is the difference between the Number of enrolments of both sexes of Secondary in 1977 and the Number of enrolments of both sexes of Secondary vocational in 1981?
Give a very brief answer. 1.39e+06. What is the difference between the Number of enrolments of both sexes of Secondary general in 1977 and the Number of enrolments of both sexes of Secondary vocational in 1981?
Offer a very short reply. 7.41e+04. What is the difference between the Number of enrolments of both sexes of Primary in 1977 and the Number of enrolments of both sexes of Secondary in 1982?
Your response must be concise. -8.97e+05. What is the difference between the Number of enrolments of both sexes of Primary in 1977 and the Number of enrolments of both sexes of Secondary general in 1982?
Your answer should be compact. 5.56e+05. What is the difference between the Number of enrolments of both sexes in Primary in 1977 and the Number of enrolments of both sexes in Secondary vocational in 1982?
Your response must be concise. 9.94e+05. What is the difference between the Number of enrolments of both sexes of Secondary in 1977 and the Number of enrolments of both sexes of Secondary general in 1982?
Make the answer very short. 1.32e+06. What is the difference between the Number of enrolments of both sexes of Secondary in 1977 and the Number of enrolments of both sexes of Secondary vocational in 1982?
Your answer should be compact. 1.76e+06. What is the difference between the Number of enrolments of both sexes of Secondary general in 1977 and the Number of enrolments of both sexes of Secondary vocational in 1982?
Your response must be concise. 4.40e+05. What is the difference between the Number of enrolments of both sexes in Primary in 1978 and the Number of enrolments of both sexes in Secondary in 1979?
Provide a short and direct response. -8.90e+05. What is the difference between the Number of enrolments of both sexes of Primary in 1978 and the Number of enrolments of both sexes of Secondary general in 1979?
Your answer should be compact. 5.84e+05. What is the difference between the Number of enrolments of both sexes in Primary in 1978 and the Number of enrolments of both sexes in Secondary vocational in 1979?
Provide a succinct answer. 5.97e+05. What is the difference between the Number of enrolments of both sexes in Secondary in 1978 and the Number of enrolments of both sexes in Secondary general in 1979?
Provide a short and direct response. 1.38e+06. What is the difference between the Number of enrolments of both sexes in Secondary in 1978 and the Number of enrolments of both sexes in Secondary vocational in 1979?
Give a very brief answer. 1.39e+06. What is the difference between the Number of enrolments of both sexes of Secondary general in 1978 and the Number of enrolments of both sexes of Secondary vocational in 1979?
Your answer should be very brief. 1.81e+04. What is the difference between the Number of enrolments of both sexes in Primary in 1978 and the Number of enrolments of both sexes in Secondary in 1980?
Offer a terse response. -8.00e+05. What is the difference between the Number of enrolments of both sexes in Primary in 1978 and the Number of enrolments of both sexes in Secondary general in 1980?
Provide a short and direct response. 5.97e+05. What is the difference between the Number of enrolments of both sexes of Primary in 1978 and the Number of enrolments of both sexes of Secondary vocational in 1980?
Your response must be concise. 5.68e+05. What is the difference between the Number of enrolments of both sexes in Secondary in 1978 and the Number of enrolments of both sexes in Secondary general in 1980?
Give a very brief answer. 1.39e+06. What is the difference between the Number of enrolments of both sexes of Secondary in 1978 and the Number of enrolments of both sexes of Secondary vocational in 1980?
Offer a terse response. 1.36e+06. What is the difference between the Number of enrolments of both sexes in Secondary general in 1978 and the Number of enrolments of both sexes in Secondary vocational in 1980?
Your response must be concise. -1.10e+04. What is the difference between the Number of enrolments of both sexes of Primary in 1978 and the Number of enrolments of both sexes of Secondary in 1981?
Provide a short and direct response. -8.14e+05. What is the difference between the Number of enrolments of both sexes of Primary in 1978 and the Number of enrolments of both sexes of Secondary general in 1981?
Your answer should be compact. 5.99e+05. What is the difference between the Number of enrolments of both sexes of Primary in 1978 and the Number of enrolments of both sexes of Secondary vocational in 1981?
Provide a succinct answer. 6.55e+05. What is the difference between the Number of enrolments of both sexes in Secondary in 1978 and the Number of enrolments of both sexes in Secondary general in 1981?
Offer a terse response. 1.39e+06. What is the difference between the Number of enrolments of both sexes of Secondary in 1978 and the Number of enrolments of both sexes of Secondary vocational in 1981?
Ensure brevity in your answer.  1.45e+06. What is the difference between the Number of enrolments of both sexes of Secondary general in 1978 and the Number of enrolments of both sexes of Secondary vocational in 1981?
Provide a short and direct response. 7.61e+04. What is the difference between the Number of enrolments of both sexes of Primary in 1978 and the Number of enrolments of both sexes of Secondary in 1982?
Give a very brief answer. -8.69e+05. What is the difference between the Number of enrolments of both sexes in Primary in 1978 and the Number of enrolments of both sexes in Secondary general in 1982?
Ensure brevity in your answer.  5.84e+05. What is the difference between the Number of enrolments of both sexes in Primary in 1978 and the Number of enrolments of both sexes in Secondary vocational in 1982?
Give a very brief answer. 1.02e+06. What is the difference between the Number of enrolments of both sexes in Secondary in 1978 and the Number of enrolments of both sexes in Secondary general in 1982?
Your response must be concise. 1.38e+06. What is the difference between the Number of enrolments of both sexes of Secondary in 1978 and the Number of enrolments of both sexes of Secondary vocational in 1982?
Make the answer very short. 1.81e+06. What is the difference between the Number of enrolments of both sexes in Secondary general in 1978 and the Number of enrolments of both sexes in Secondary vocational in 1982?
Provide a short and direct response. 4.42e+05. What is the difference between the Number of enrolments of both sexes in Primary in 1979 and the Number of enrolments of both sexes in Secondary in 1980?
Provide a succinct answer. -7.88e+05. What is the difference between the Number of enrolments of both sexes in Primary in 1979 and the Number of enrolments of both sexes in Secondary general in 1980?
Provide a short and direct response. 6.09e+05. What is the difference between the Number of enrolments of both sexes in Primary in 1979 and the Number of enrolments of both sexes in Secondary vocational in 1980?
Your answer should be compact. 5.80e+05. What is the difference between the Number of enrolments of both sexes of Secondary in 1979 and the Number of enrolments of both sexes of Secondary general in 1980?
Provide a succinct answer. 1.49e+06. What is the difference between the Number of enrolments of both sexes of Secondary in 1979 and the Number of enrolments of both sexes of Secondary vocational in 1980?
Your answer should be compact. 1.46e+06. What is the difference between the Number of enrolments of both sexes in Secondary general in 1979 and the Number of enrolments of both sexes in Secondary vocational in 1980?
Give a very brief answer. -1.57e+04. What is the difference between the Number of enrolments of both sexes in Primary in 1979 and the Number of enrolments of both sexes in Secondary in 1981?
Provide a succinct answer. -8.02e+05. What is the difference between the Number of enrolments of both sexes of Primary in 1979 and the Number of enrolments of both sexes of Secondary general in 1981?
Keep it short and to the point. 6.11e+05. What is the difference between the Number of enrolments of both sexes in Primary in 1979 and the Number of enrolments of both sexes in Secondary vocational in 1981?
Your response must be concise. 6.67e+05. What is the difference between the Number of enrolments of both sexes of Secondary in 1979 and the Number of enrolments of both sexes of Secondary general in 1981?
Offer a very short reply. 1.49e+06. What is the difference between the Number of enrolments of both sexes of Secondary in 1979 and the Number of enrolments of both sexes of Secondary vocational in 1981?
Your response must be concise. 1.55e+06. What is the difference between the Number of enrolments of both sexes in Secondary general in 1979 and the Number of enrolments of both sexes in Secondary vocational in 1981?
Your answer should be very brief. 7.14e+04. What is the difference between the Number of enrolments of both sexes in Primary in 1979 and the Number of enrolments of both sexes in Secondary in 1982?
Give a very brief answer. -8.58e+05. What is the difference between the Number of enrolments of both sexes in Primary in 1979 and the Number of enrolments of both sexes in Secondary general in 1982?
Offer a terse response. 5.95e+05. What is the difference between the Number of enrolments of both sexes in Primary in 1979 and the Number of enrolments of both sexes in Secondary vocational in 1982?
Your answer should be compact. 1.03e+06. What is the difference between the Number of enrolments of both sexes in Secondary in 1979 and the Number of enrolments of both sexes in Secondary general in 1982?
Offer a very short reply. 1.47e+06. What is the difference between the Number of enrolments of both sexes in Secondary in 1979 and the Number of enrolments of both sexes in Secondary vocational in 1982?
Provide a succinct answer. 1.91e+06. What is the difference between the Number of enrolments of both sexes in Secondary general in 1979 and the Number of enrolments of both sexes in Secondary vocational in 1982?
Your answer should be very brief. 4.37e+05. What is the difference between the Number of enrolments of both sexes in Primary in 1980 and the Number of enrolments of both sexes in Secondary in 1981?
Make the answer very short. -7.95e+05. What is the difference between the Number of enrolments of both sexes in Primary in 1980 and the Number of enrolments of both sexes in Secondary general in 1981?
Give a very brief answer. 6.18e+05. What is the difference between the Number of enrolments of both sexes in Primary in 1980 and the Number of enrolments of both sexes in Secondary vocational in 1981?
Your response must be concise. 6.74e+05. What is the difference between the Number of enrolments of both sexes in Secondary in 1980 and the Number of enrolments of both sexes in Secondary general in 1981?
Your answer should be very brief. 1.40e+06. What is the difference between the Number of enrolments of both sexes in Secondary in 1980 and the Number of enrolments of both sexes in Secondary vocational in 1981?
Ensure brevity in your answer.  1.46e+06. What is the difference between the Number of enrolments of both sexes in Secondary general in 1980 and the Number of enrolments of both sexes in Secondary vocational in 1981?
Your answer should be compact. 5.82e+04. What is the difference between the Number of enrolments of both sexes in Primary in 1980 and the Number of enrolments of both sexes in Secondary in 1982?
Ensure brevity in your answer.  -8.50e+05. What is the difference between the Number of enrolments of both sexes in Primary in 1980 and the Number of enrolments of both sexes in Secondary general in 1982?
Keep it short and to the point. 6.03e+05. What is the difference between the Number of enrolments of both sexes in Primary in 1980 and the Number of enrolments of both sexes in Secondary vocational in 1982?
Offer a very short reply. 1.04e+06. What is the difference between the Number of enrolments of both sexes in Secondary in 1980 and the Number of enrolments of both sexes in Secondary general in 1982?
Give a very brief answer. 1.38e+06. What is the difference between the Number of enrolments of both sexes of Secondary in 1980 and the Number of enrolments of both sexes of Secondary vocational in 1982?
Make the answer very short. 1.82e+06. What is the difference between the Number of enrolments of both sexes of Secondary general in 1980 and the Number of enrolments of both sexes of Secondary vocational in 1982?
Offer a terse response. 4.24e+05. What is the difference between the Number of enrolments of both sexes of Primary in 1981 and the Number of enrolments of both sexes of Secondary in 1982?
Provide a succinct answer. -8.58e+05. What is the difference between the Number of enrolments of both sexes of Primary in 1981 and the Number of enrolments of both sexes of Secondary general in 1982?
Ensure brevity in your answer.  5.95e+05. What is the difference between the Number of enrolments of both sexes of Primary in 1981 and the Number of enrolments of both sexes of Secondary vocational in 1982?
Your answer should be very brief. 1.03e+06. What is the difference between the Number of enrolments of both sexes in Secondary in 1981 and the Number of enrolments of both sexes in Secondary general in 1982?
Ensure brevity in your answer.  1.40e+06. What is the difference between the Number of enrolments of both sexes in Secondary in 1981 and the Number of enrolments of both sexes in Secondary vocational in 1982?
Ensure brevity in your answer.  1.84e+06. What is the difference between the Number of enrolments of both sexes of Secondary general in 1981 and the Number of enrolments of both sexes of Secondary vocational in 1982?
Your answer should be very brief. 4.23e+05. What is the average Number of enrolments of both sexes of Primary per year?
Your answer should be compact. 1.67e+06. What is the average Number of enrolments of both sexes in Secondary per year?
Ensure brevity in your answer.  2.44e+06. What is the average Number of enrolments of both sexes of Secondary general per year?
Your answer should be compact. 1.10e+06. What is the average Number of enrolments of both sexes of Secondary vocational per year?
Provide a short and direct response. 1.05e+06. In the year 1974, what is the difference between the Number of enrolments of both sexes in Primary and Number of enrolments of both sexes in Secondary?
Provide a succinct answer. -5.86e+05. In the year 1974, what is the difference between the Number of enrolments of both sexes of Primary and Number of enrolments of both sexes of Secondary general?
Your answer should be very brief. 5.58e+05. In the year 1974, what is the difference between the Number of enrolments of both sexes in Primary and Number of enrolments of both sexes in Secondary vocational?
Provide a succinct answer. 6.11e+05. In the year 1974, what is the difference between the Number of enrolments of both sexes of Secondary and Number of enrolments of both sexes of Secondary general?
Your answer should be compact. 1.14e+06. In the year 1974, what is the difference between the Number of enrolments of both sexes of Secondary and Number of enrolments of both sexes of Secondary vocational?
Give a very brief answer. 1.20e+06. In the year 1974, what is the difference between the Number of enrolments of both sexes in Secondary general and Number of enrolments of both sexes in Secondary vocational?
Ensure brevity in your answer.  5.33e+04. In the year 1975, what is the difference between the Number of enrolments of both sexes of Primary and Number of enrolments of both sexes of Secondary?
Provide a short and direct response. -6.48e+05. In the year 1975, what is the difference between the Number of enrolments of both sexes in Primary and Number of enrolments of both sexes in Secondary general?
Keep it short and to the point. 5.74e+05. In the year 1975, what is the difference between the Number of enrolments of both sexes of Primary and Number of enrolments of both sexes of Secondary vocational?
Offer a very short reply. 5.81e+05. In the year 1975, what is the difference between the Number of enrolments of both sexes of Secondary and Number of enrolments of both sexes of Secondary general?
Keep it short and to the point. 1.22e+06. In the year 1975, what is the difference between the Number of enrolments of both sexes in Secondary and Number of enrolments of both sexes in Secondary vocational?
Make the answer very short. 1.23e+06. In the year 1975, what is the difference between the Number of enrolments of both sexes in Secondary general and Number of enrolments of both sexes in Secondary vocational?
Offer a very short reply. 7323. In the year 1976, what is the difference between the Number of enrolments of both sexes of Primary and Number of enrolments of both sexes of Secondary?
Ensure brevity in your answer.  -7.29e+05. In the year 1976, what is the difference between the Number of enrolments of both sexes in Primary and Number of enrolments of both sexes in Secondary general?
Offer a terse response. 5.39e+05. In the year 1976, what is the difference between the Number of enrolments of both sexes of Primary and Number of enrolments of both sexes of Secondary vocational?
Provide a short and direct response. 5.18e+05. In the year 1976, what is the difference between the Number of enrolments of both sexes of Secondary and Number of enrolments of both sexes of Secondary general?
Give a very brief answer. 1.27e+06. In the year 1976, what is the difference between the Number of enrolments of both sexes in Secondary and Number of enrolments of both sexes in Secondary vocational?
Provide a short and direct response. 1.25e+06. In the year 1976, what is the difference between the Number of enrolments of both sexes in Secondary general and Number of enrolments of both sexes in Secondary vocational?
Your answer should be compact. -2.08e+04. In the year 1977, what is the difference between the Number of enrolments of both sexes in Primary and Number of enrolments of both sexes in Secondary?
Offer a very short reply. -7.62e+05. In the year 1977, what is the difference between the Number of enrolments of both sexes in Primary and Number of enrolments of both sexes in Secondary general?
Provide a succinct answer. 5.53e+05. In the year 1977, what is the difference between the Number of enrolments of both sexes in Primary and Number of enrolments of both sexes in Secondary vocational?
Make the answer very short. 4.58e+05. In the year 1977, what is the difference between the Number of enrolments of both sexes in Secondary and Number of enrolments of both sexes in Secondary general?
Your response must be concise. 1.32e+06. In the year 1977, what is the difference between the Number of enrolments of both sexes of Secondary and Number of enrolments of both sexes of Secondary vocational?
Provide a succinct answer. 1.22e+06. In the year 1977, what is the difference between the Number of enrolments of both sexes of Secondary general and Number of enrolments of both sexes of Secondary vocational?
Provide a succinct answer. -9.50e+04. In the year 1978, what is the difference between the Number of enrolments of both sexes of Primary and Number of enrolments of both sexes of Secondary?
Give a very brief answer. -7.92e+05. In the year 1978, what is the difference between the Number of enrolments of both sexes in Primary and Number of enrolments of both sexes in Secondary general?
Offer a very short reply. 5.79e+05. In the year 1978, what is the difference between the Number of enrolments of both sexes of Primary and Number of enrolments of both sexes of Secondary vocational?
Ensure brevity in your answer.  5.88e+05. In the year 1978, what is the difference between the Number of enrolments of both sexes in Secondary and Number of enrolments of both sexes in Secondary general?
Give a very brief answer. 1.37e+06. In the year 1978, what is the difference between the Number of enrolments of both sexes of Secondary and Number of enrolments of both sexes of Secondary vocational?
Give a very brief answer. 1.38e+06. In the year 1978, what is the difference between the Number of enrolments of both sexes in Secondary general and Number of enrolments of both sexes in Secondary vocational?
Offer a terse response. 9286. In the year 1979, what is the difference between the Number of enrolments of both sexes in Primary and Number of enrolments of both sexes in Secondary?
Your answer should be compact. -8.78e+05. In the year 1979, what is the difference between the Number of enrolments of both sexes of Primary and Number of enrolments of both sexes of Secondary general?
Make the answer very short. 5.96e+05. In the year 1979, what is the difference between the Number of enrolments of both sexes in Primary and Number of enrolments of both sexes in Secondary vocational?
Offer a very short reply. 6.09e+05. In the year 1979, what is the difference between the Number of enrolments of both sexes in Secondary and Number of enrolments of both sexes in Secondary general?
Offer a very short reply. 1.47e+06. In the year 1979, what is the difference between the Number of enrolments of both sexes in Secondary and Number of enrolments of both sexes in Secondary vocational?
Your answer should be compact. 1.49e+06. In the year 1979, what is the difference between the Number of enrolments of both sexes of Secondary general and Number of enrolments of both sexes of Secondary vocational?
Offer a very short reply. 1.33e+04. In the year 1980, what is the difference between the Number of enrolments of both sexes in Primary and Number of enrolments of both sexes in Secondary?
Give a very brief answer. -7.81e+05. In the year 1980, what is the difference between the Number of enrolments of both sexes in Primary and Number of enrolments of both sexes in Secondary general?
Ensure brevity in your answer.  6.16e+05. In the year 1980, what is the difference between the Number of enrolments of both sexes of Primary and Number of enrolments of both sexes of Secondary vocational?
Ensure brevity in your answer.  5.87e+05. In the year 1980, what is the difference between the Number of enrolments of both sexes of Secondary and Number of enrolments of both sexes of Secondary general?
Offer a very short reply. 1.40e+06. In the year 1980, what is the difference between the Number of enrolments of both sexes of Secondary and Number of enrolments of both sexes of Secondary vocational?
Your answer should be very brief. 1.37e+06. In the year 1980, what is the difference between the Number of enrolments of both sexes in Secondary general and Number of enrolments of both sexes in Secondary vocational?
Provide a short and direct response. -2.89e+04. In the year 1981, what is the difference between the Number of enrolments of both sexes of Primary and Number of enrolments of both sexes of Secondary?
Keep it short and to the point. -8.03e+05. In the year 1981, what is the difference between the Number of enrolments of both sexes in Primary and Number of enrolments of both sexes in Secondary general?
Keep it short and to the point. 6.11e+05. In the year 1981, what is the difference between the Number of enrolments of both sexes of Primary and Number of enrolments of both sexes of Secondary vocational?
Your answer should be compact. 6.67e+05. In the year 1981, what is the difference between the Number of enrolments of both sexes of Secondary and Number of enrolments of both sexes of Secondary general?
Your response must be concise. 1.41e+06. In the year 1981, what is the difference between the Number of enrolments of both sexes in Secondary and Number of enrolments of both sexes in Secondary vocational?
Your answer should be very brief. 1.47e+06. In the year 1981, what is the difference between the Number of enrolments of both sexes of Secondary general and Number of enrolments of both sexes of Secondary vocational?
Keep it short and to the point. 5.65e+04. In the year 1982, what is the difference between the Number of enrolments of both sexes of Primary and Number of enrolments of both sexes of Secondary?
Give a very brief answer. -8.78e+05. In the year 1982, what is the difference between the Number of enrolments of both sexes in Primary and Number of enrolments of both sexes in Secondary general?
Give a very brief answer. 5.75e+05. In the year 1982, what is the difference between the Number of enrolments of both sexes in Primary and Number of enrolments of both sexes in Secondary vocational?
Make the answer very short. 1.01e+06. In the year 1982, what is the difference between the Number of enrolments of both sexes of Secondary and Number of enrolments of both sexes of Secondary general?
Keep it short and to the point. 1.45e+06. In the year 1982, what is the difference between the Number of enrolments of both sexes of Secondary and Number of enrolments of both sexes of Secondary vocational?
Make the answer very short. 1.89e+06. In the year 1982, what is the difference between the Number of enrolments of both sexes in Secondary general and Number of enrolments of both sexes in Secondary vocational?
Your response must be concise. 4.38e+05. What is the ratio of the Number of enrolments of both sexes of Primary in 1974 to that in 1975?
Offer a very short reply. 0.98. What is the ratio of the Number of enrolments of both sexes of Secondary in 1974 to that in 1975?
Your answer should be very brief. 0.96. What is the ratio of the Number of enrolments of both sexes in Secondary general in 1974 to that in 1975?
Make the answer very short. 0.98. What is the ratio of the Number of enrolments of both sexes in Secondary vocational in 1974 to that in 1975?
Ensure brevity in your answer.  0.94. What is the ratio of the Number of enrolments of both sexes in Secondary in 1974 to that in 1976?
Keep it short and to the point. 0.92. What is the ratio of the Number of enrolments of both sexes in Secondary general in 1974 to that in 1976?
Give a very brief answer. 0.94. What is the ratio of the Number of enrolments of both sexes of Secondary vocational in 1974 to that in 1976?
Your answer should be very brief. 0.88. What is the ratio of the Number of enrolments of both sexes in Primary in 1974 to that in 1977?
Make the answer very short. 0.95. What is the ratio of the Number of enrolments of both sexes of Secondary in 1974 to that in 1977?
Your answer should be compact. 0.9. What is the ratio of the Number of enrolments of both sexes in Secondary general in 1974 to that in 1977?
Your answer should be very brief. 0.93. What is the ratio of the Number of enrolments of both sexes of Secondary vocational in 1974 to that in 1977?
Provide a short and direct response. 0.81. What is the ratio of the Number of enrolments of both sexes of Primary in 1974 to that in 1978?
Offer a terse response. 0.94. What is the ratio of the Number of enrolments of both sexes of Secondary in 1974 to that in 1978?
Provide a succinct answer. 0.88. What is the ratio of the Number of enrolments of both sexes of Secondary general in 1974 to that in 1978?
Give a very brief answer. 0.93. What is the ratio of the Number of enrolments of both sexes of Secondary vocational in 1974 to that in 1978?
Offer a very short reply. 0.89. What is the ratio of the Number of enrolments of both sexes of Primary in 1974 to that in 1979?
Provide a short and direct response. 0.93. What is the ratio of the Number of enrolments of both sexes in Secondary in 1974 to that in 1979?
Ensure brevity in your answer.  0.84. What is the ratio of the Number of enrolments of both sexes of Secondary general in 1974 to that in 1979?
Make the answer very short. 0.93. What is the ratio of the Number of enrolments of both sexes of Secondary vocational in 1974 to that in 1979?
Your answer should be compact. 0.89. What is the ratio of the Number of enrolments of both sexes in Primary in 1974 to that in 1980?
Your response must be concise. 0.93. What is the ratio of the Number of enrolments of both sexes of Secondary in 1974 to that in 1980?
Offer a terse response. 0.87. What is the ratio of the Number of enrolments of both sexes in Secondary general in 1974 to that in 1980?
Your answer should be compact. 0.94. What is the ratio of the Number of enrolments of both sexes in Secondary vocational in 1974 to that in 1980?
Keep it short and to the point. 0.87. What is the ratio of the Number of enrolments of both sexes in Primary in 1974 to that in 1981?
Give a very brief answer. 0.93. What is the ratio of the Number of enrolments of both sexes of Secondary in 1974 to that in 1981?
Ensure brevity in your answer.  0.87. What is the ratio of the Number of enrolments of both sexes of Secondary general in 1974 to that in 1981?
Your answer should be compact. 0.94. What is the ratio of the Number of enrolments of both sexes in Secondary vocational in 1974 to that in 1981?
Provide a short and direct response. 0.94. What is the ratio of the Number of enrolments of both sexes of Primary in 1974 to that in 1982?
Ensure brevity in your answer.  0.94. What is the ratio of the Number of enrolments of both sexes of Secondary in 1974 to that in 1982?
Make the answer very short. 0.85. What is the ratio of the Number of enrolments of both sexes in Secondary vocational in 1974 to that in 1982?
Provide a short and direct response. 1.45. What is the ratio of the Number of enrolments of both sexes of Secondary in 1975 to that in 1976?
Your answer should be very brief. 0.96. What is the ratio of the Number of enrolments of both sexes in Secondary vocational in 1975 to that in 1976?
Your answer should be compact. 0.94. What is the ratio of the Number of enrolments of both sexes in Primary in 1975 to that in 1977?
Your answer should be compact. 0.98. What is the ratio of the Number of enrolments of both sexes of Secondary in 1975 to that in 1977?
Give a very brief answer. 0.94. What is the ratio of the Number of enrolments of both sexes of Secondary general in 1975 to that in 1977?
Your answer should be very brief. 0.95. What is the ratio of the Number of enrolments of both sexes in Secondary vocational in 1975 to that in 1977?
Give a very brief answer. 0.87. What is the ratio of the Number of enrolments of both sexes of Primary in 1975 to that in 1978?
Your answer should be very brief. 0.96. What is the ratio of the Number of enrolments of both sexes of Secondary in 1975 to that in 1978?
Your answer should be very brief. 0.92. What is the ratio of the Number of enrolments of both sexes in Secondary general in 1975 to that in 1978?
Offer a very short reply. 0.95. What is the ratio of the Number of enrolments of both sexes of Secondary vocational in 1975 to that in 1978?
Give a very brief answer. 0.95. What is the ratio of the Number of enrolments of both sexes of Primary in 1975 to that in 1979?
Provide a succinct answer. 0.95. What is the ratio of the Number of enrolments of both sexes in Secondary in 1975 to that in 1979?
Keep it short and to the point. 0.88. What is the ratio of the Number of enrolments of both sexes in Secondary general in 1975 to that in 1979?
Offer a terse response. 0.95. What is the ratio of the Number of enrolments of both sexes in Secondary vocational in 1975 to that in 1979?
Your answer should be very brief. 0.95. What is the ratio of the Number of enrolments of both sexes in Primary in 1975 to that in 1980?
Give a very brief answer. 0.95. What is the ratio of the Number of enrolments of both sexes in Secondary in 1975 to that in 1980?
Your response must be concise. 0.91. What is the ratio of the Number of enrolments of both sexes in Secondary general in 1975 to that in 1980?
Offer a terse response. 0.96. What is the ratio of the Number of enrolments of both sexes in Secondary vocational in 1975 to that in 1980?
Your response must be concise. 0.93. What is the ratio of the Number of enrolments of both sexes of Primary in 1975 to that in 1981?
Your answer should be very brief. 0.95. What is the ratio of the Number of enrolments of both sexes of Secondary in 1975 to that in 1981?
Give a very brief answer. 0.91. What is the ratio of the Number of enrolments of both sexes in Secondary general in 1975 to that in 1981?
Provide a short and direct response. 0.96. What is the ratio of the Number of enrolments of both sexes of Secondary vocational in 1975 to that in 1981?
Make the answer very short. 1.01. What is the ratio of the Number of enrolments of both sexes of Primary in 1975 to that in 1982?
Your answer should be very brief. 0.97. What is the ratio of the Number of enrolments of both sexes of Secondary in 1975 to that in 1982?
Offer a terse response. 0.89. What is the ratio of the Number of enrolments of both sexes of Secondary general in 1975 to that in 1982?
Your response must be concise. 0.95. What is the ratio of the Number of enrolments of both sexes in Secondary vocational in 1975 to that in 1982?
Ensure brevity in your answer.  1.55. What is the ratio of the Number of enrolments of both sexes in Primary in 1976 to that in 1977?
Give a very brief answer. 0.98. What is the ratio of the Number of enrolments of both sexes in Secondary in 1976 to that in 1977?
Make the answer very short. 0.97. What is the ratio of the Number of enrolments of both sexes in Secondary general in 1976 to that in 1977?
Keep it short and to the point. 0.98. What is the ratio of the Number of enrolments of both sexes in Secondary vocational in 1976 to that in 1977?
Offer a very short reply. 0.92. What is the ratio of the Number of enrolments of both sexes in Primary in 1976 to that in 1978?
Provide a short and direct response. 0.96. What is the ratio of the Number of enrolments of both sexes in Secondary in 1976 to that in 1978?
Give a very brief answer. 0.95. What is the ratio of the Number of enrolments of both sexes in Secondary general in 1976 to that in 1978?
Provide a short and direct response. 0.98. What is the ratio of the Number of enrolments of both sexes in Secondary vocational in 1976 to that in 1978?
Provide a succinct answer. 1.01. What is the ratio of the Number of enrolments of both sexes in Primary in 1976 to that in 1979?
Offer a very short reply. 0.96. What is the ratio of the Number of enrolments of both sexes in Secondary in 1976 to that in 1979?
Offer a very short reply. 0.91. What is the ratio of the Number of enrolments of both sexes of Secondary general in 1976 to that in 1979?
Offer a terse response. 0.99. What is the ratio of the Number of enrolments of both sexes in Secondary vocational in 1976 to that in 1979?
Your answer should be very brief. 1.02. What is the ratio of the Number of enrolments of both sexes of Primary in 1976 to that in 1980?
Provide a short and direct response. 0.95. What is the ratio of the Number of enrolments of both sexes in Secondary in 1976 to that in 1980?
Offer a terse response. 0.95. What is the ratio of the Number of enrolments of both sexes of Secondary vocational in 1976 to that in 1980?
Offer a very short reply. 0.99. What is the ratio of the Number of enrolments of both sexes in Primary in 1976 to that in 1981?
Your answer should be compact. 0.96. What is the ratio of the Number of enrolments of both sexes of Secondary in 1976 to that in 1981?
Provide a short and direct response. 0.94. What is the ratio of the Number of enrolments of both sexes in Secondary general in 1976 to that in 1981?
Provide a short and direct response. 1. What is the ratio of the Number of enrolments of both sexes of Secondary vocational in 1976 to that in 1981?
Your answer should be compact. 1.07. What is the ratio of the Number of enrolments of both sexes in Primary in 1976 to that in 1982?
Provide a succinct answer. 0.97. What is the ratio of the Number of enrolments of both sexes in Secondary in 1976 to that in 1982?
Provide a short and direct response. 0.92. What is the ratio of the Number of enrolments of both sexes in Secondary general in 1976 to that in 1982?
Make the answer very short. 0.99. What is the ratio of the Number of enrolments of both sexes in Secondary vocational in 1976 to that in 1982?
Provide a short and direct response. 1.65. What is the ratio of the Number of enrolments of both sexes of Primary in 1977 to that in 1978?
Your answer should be compact. 0.98. What is the ratio of the Number of enrolments of both sexes in Secondary in 1977 to that in 1978?
Make the answer very short. 0.98. What is the ratio of the Number of enrolments of both sexes in Secondary vocational in 1977 to that in 1978?
Your answer should be very brief. 1.09. What is the ratio of the Number of enrolments of both sexes in Primary in 1977 to that in 1979?
Your answer should be very brief. 0.98. What is the ratio of the Number of enrolments of both sexes in Secondary in 1977 to that in 1979?
Ensure brevity in your answer.  0.94. What is the ratio of the Number of enrolments of both sexes of Secondary vocational in 1977 to that in 1979?
Give a very brief answer. 1.1. What is the ratio of the Number of enrolments of both sexes in Primary in 1977 to that in 1980?
Your answer should be compact. 0.97. What is the ratio of the Number of enrolments of both sexes in Secondary in 1977 to that in 1980?
Provide a short and direct response. 0.97. What is the ratio of the Number of enrolments of both sexes of Secondary general in 1977 to that in 1980?
Offer a terse response. 1.01. What is the ratio of the Number of enrolments of both sexes of Secondary vocational in 1977 to that in 1980?
Your answer should be very brief. 1.07. What is the ratio of the Number of enrolments of both sexes in Primary in 1977 to that in 1981?
Your answer should be very brief. 0.98. What is the ratio of the Number of enrolments of both sexes of Secondary in 1977 to that in 1981?
Your response must be concise. 0.97. What is the ratio of the Number of enrolments of both sexes of Secondary general in 1977 to that in 1981?
Your answer should be very brief. 1.02. What is the ratio of the Number of enrolments of both sexes in Secondary vocational in 1977 to that in 1981?
Your answer should be compact. 1.16. What is the ratio of the Number of enrolments of both sexes in Primary in 1977 to that in 1982?
Provide a short and direct response. 0.99. What is the ratio of the Number of enrolments of both sexes in Secondary in 1977 to that in 1982?
Offer a terse response. 0.95. What is the ratio of the Number of enrolments of both sexes in Secondary general in 1977 to that in 1982?
Your answer should be compact. 1. What is the ratio of the Number of enrolments of both sexes of Secondary vocational in 1977 to that in 1982?
Your response must be concise. 1.79. What is the ratio of the Number of enrolments of both sexes in Secondary in 1978 to that in 1979?
Provide a succinct answer. 0.96. What is the ratio of the Number of enrolments of both sexes in Secondary general in 1978 to that in 1979?
Your answer should be very brief. 1. What is the ratio of the Number of enrolments of both sexes in Secondary vocational in 1978 to that in 1979?
Your response must be concise. 1.01. What is the ratio of the Number of enrolments of both sexes in Primary in 1978 to that in 1980?
Offer a terse response. 0.99. What is the ratio of the Number of enrolments of both sexes of Secondary general in 1978 to that in 1980?
Give a very brief answer. 1.02. What is the ratio of the Number of enrolments of both sexes of Secondary vocational in 1978 to that in 1980?
Keep it short and to the point. 0.98. What is the ratio of the Number of enrolments of both sexes of Secondary in 1978 to that in 1981?
Provide a short and direct response. 0.99. What is the ratio of the Number of enrolments of both sexes in Secondary general in 1978 to that in 1981?
Keep it short and to the point. 1.02. What is the ratio of the Number of enrolments of both sexes of Secondary vocational in 1978 to that in 1981?
Your answer should be compact. 1.06. What is the ratio of the Number of enrolments of both sexes of Primary in 1978 to that in 1982?
Your answer should be compact. 1. What is the ratio of the Number of enrolments of both sexes in Secondary in 1978 to that in 1982?
Provide a short and direct response. 0.97. What is the ratio of the Number of enrolments of both sexes of Secondary general in 1978 to that in 1982?
Make the answer very short. 1. What is the ratio of the Number of enrolments of both sexes of Secondary vocational in 1978 to that in 1982?
Offer a terse response. 1.64. What is the ratio of the Number of enrolments of both sexes of Secondary in 1979 to that in 1980?
Make the answer very short. 1.04. What is the ratio of the Number of enrolments of both sexes in Secondary vocational in 1979 to that in 1980?
Make the answer very short. 0.97. What is the ratio of the Number of enrolments of both sexes of Secondary in 1979 to that in 1981?
Offer a very short reply. 1.03. What is the ratio of the Number of enrolments of both sexes in Secondary general in 1979 to that in 1981?
Give a very brief answer. 1.01. What is the ratio of the Number of enrolments of both sexes of Secondary vocational in 1979 to that in 1981?
Offer a very short reply. 1.06. What is the ratio of the Number of enrolments of both sexes in Primary in 1979 to that in 1982?
Provide a succinct answer. 1.01. What is the ratio of the Number of enrolments of both sexes in Secondary vocational in 1979 to that in 1982?
Make the answer very short. 1.63. What is the ratio of the Number of enrolments of both sexes in Primary in 1980 to that in 1981?
Your response must be concise. 1. What is the ratio of the Number of enrolments of both sexes in Secondary in 1980 to that in 1981?
Your answer should be compact. 0.99. What is the ratio of the Number of enrolments of both sexes of Secondary general in 1980 to that in 1981?
Offer a very short reply. 1. What is the ratio of the Number of enrolments of both sexes in Secondary vocational in 1980 to that in 1981?
Keep it short and to the point. 1.08. What is the ratio of the Number of enrolments of both sexes of Primary in 1980 to that in 1982?
Your answer should be very brief. 1.02. What is the ratio of the Number of enrolments of both sexes in Secondary in 1980 to that in 1982?
Your answer should be very brief. 0.97. What is the ratio of the Number of enrolments of both sexes in Secondary vocational in 1980 to that in 1982?
Give a very brief answer. 1.67. What is the ratio of the Number of enrolments of both sexes of Primary in 1981 to that in 1982?
Provide a short and direct response. 1.01. What is the ratio of the Number of enrolments of both sexes of Secondary in 1981 to that in 1982?
Keep it short and to the point. 0.98. What is the ratio of the Number of enrolments of both sexes in Secondary general in 1981 to that in 1982?
Ensure brevity in your answer.  0.99. What is the ratio of the Number of enrolments of both sexes of Secondary vocational in 1981 to that in 1982?
Your response must be concise. 1.54. What is the difference between the highest and the second highest Number of enrolments of both sexes in Primary?
Ensure brevity in your answer.  7120. What is the difference between the highest and the second highest Number of enrolments of both sexes in Secondary?
Provide a short and direct response. 2.07e+04. What is the difference between the highest and the second highest Number of enrolments of both sexes of Secondary general?
Make the answer very short. 2012. What is the difference between the highest and the second highest Number of enrolments of both sexes in Secondary vocational?
Your answer should be very brief. 8.21e+04. What is the difference between the highest and the lowest Number of enrolments of both sexes of Primary?
Keep it short and to the point. 1.22e+05. What is the difference between the highest and the lowest Number of enrolments of both sexes of Secondary?
Make the answer very short. 4.07e+05. What is the difference between the highest and the lowest Number of enrolments of both sexes of Secondary general?
Provide a short and direct response. 8.14e+04. What is the difference between the highest and the lowest Number of enrolments of both sexes of Secondary vocational?
Provide a short and direct response. 5.35e+05. 